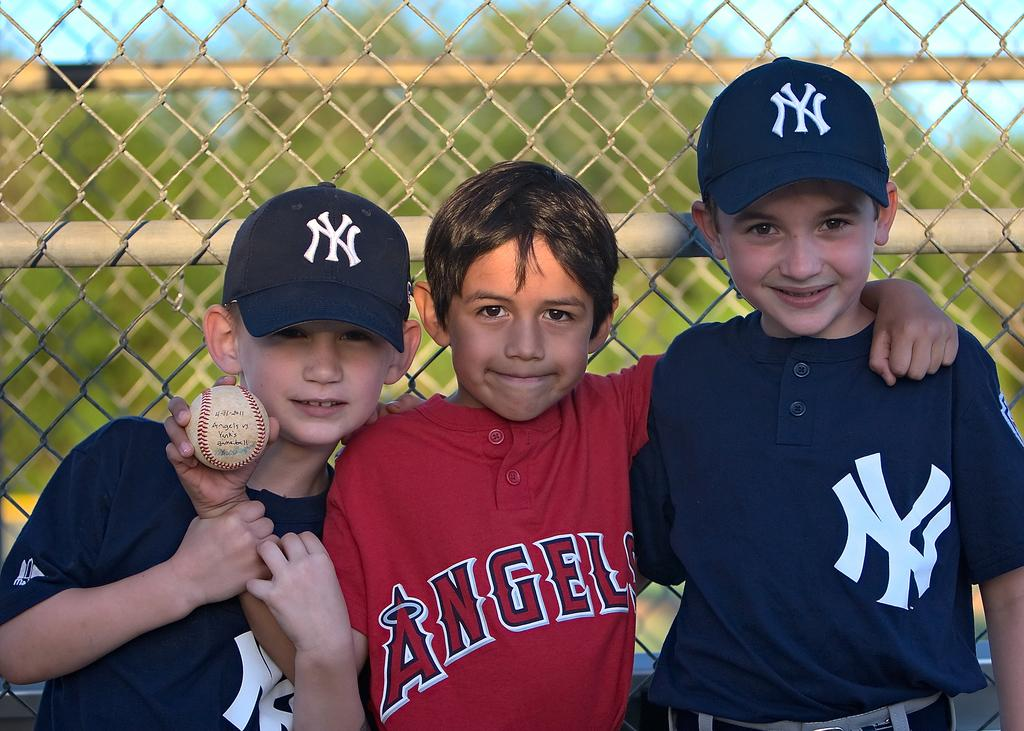Provide a one-sentence caption for the provided image. Two NY Yankee fans and an Angels fan are standing in front of a fence with their arms around each other. 